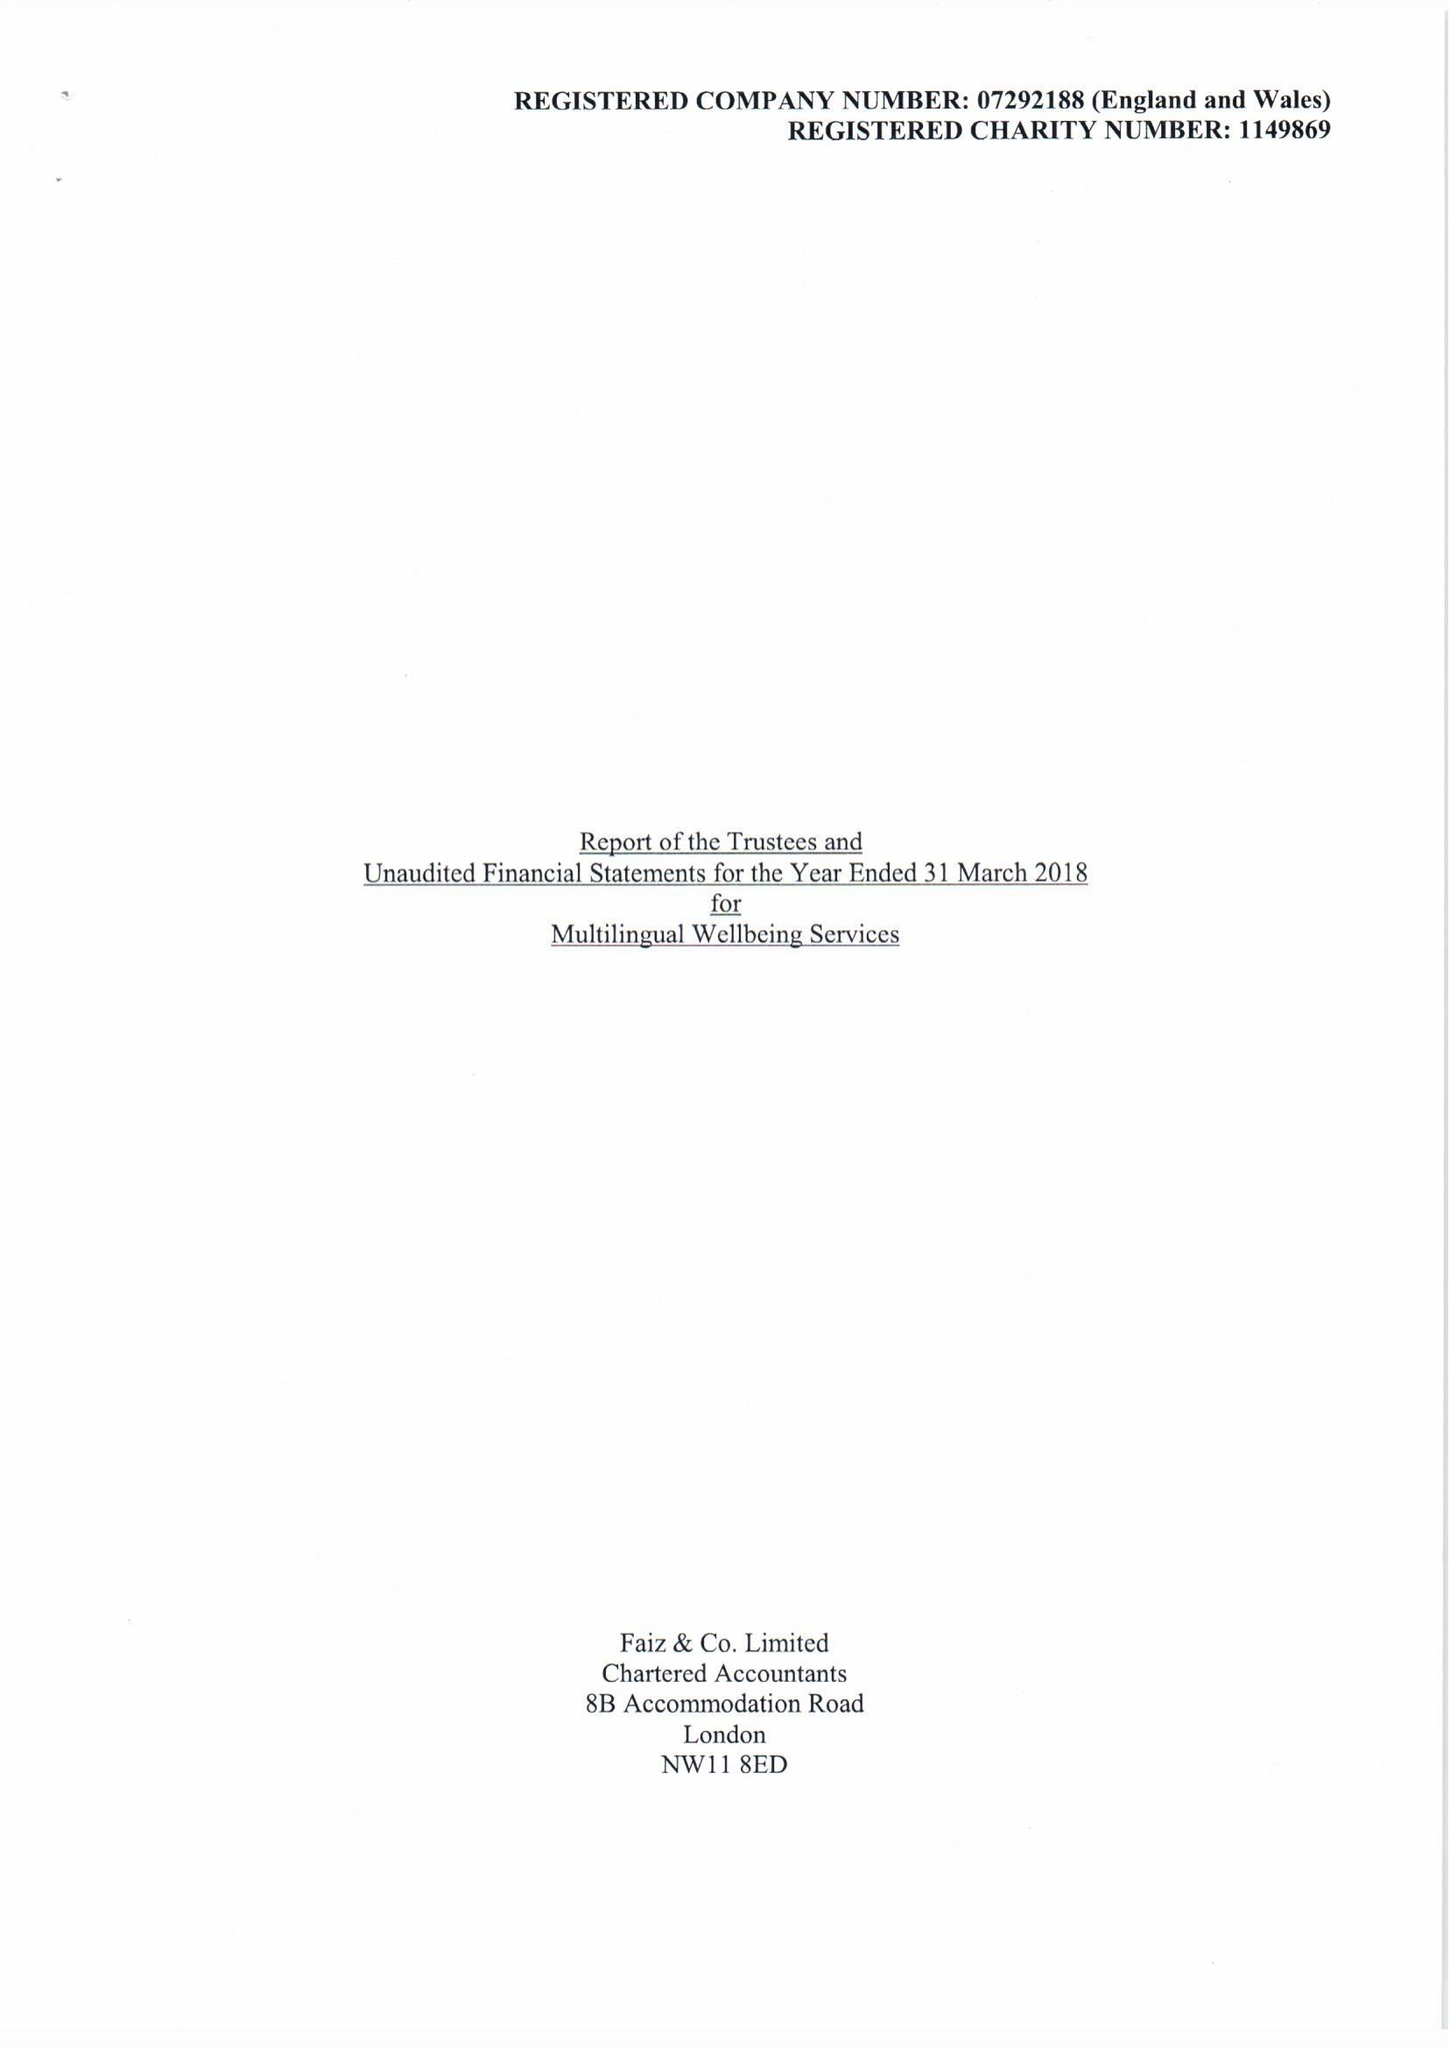What is the value for the charity_number?
Answer the question using a single word or phrase. 1149869 